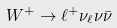Convert formula to latex. <formula><loc_0><loc_0><loc_500><loc_500>W ^ { + } \rightarrow \ell ^ { + } \nu _ { \ell } \nu \bar { \nu }</formula> 